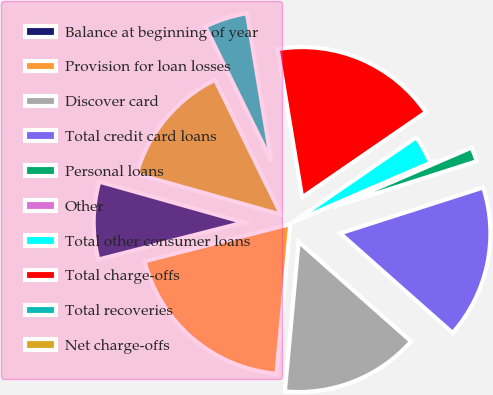Convert chart. <chart><loc_0><loc_0><loc_500><loc_500><pie_chart><fcel>Balance at beginning of year<fcel>Provision for loan losses<fcel>Discover card<fcel>Total credit card loans<fcel>Personal loans<fcel>Other<fcel>Total other consumer loans<fcel>Total charge-offs<fcel>Total recoveries<fcel>Net charge-offs<nl><fcel>8.34%<fcel>19.57%<fcel>14.92%<fcel>16.47%<fcel>1.55%<fcel>0.0%<fcel>3.1%<fcel>18.02%<fcel>4.65%<fcel>13.37%<nl></chart> 